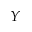Convert formula to latex. <formula><loc_0><loc_0><loc_500><loc_500>Y</formula> 